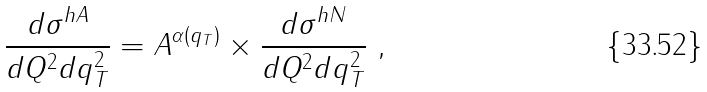<formula> <loc_0><loc_0><loc_500><loc_500>\frac { d \sigma ^ { h A } } { d Q ^ { 2 } d q _ { T } ^ { 2 } } = A ^ { \alpha ( q _ { T } ) } \times \frac { d \sigma ^ { h N } } { d Q ^ { 2 } d q _ { T } ^ { 2 } } \ ,</formula> 